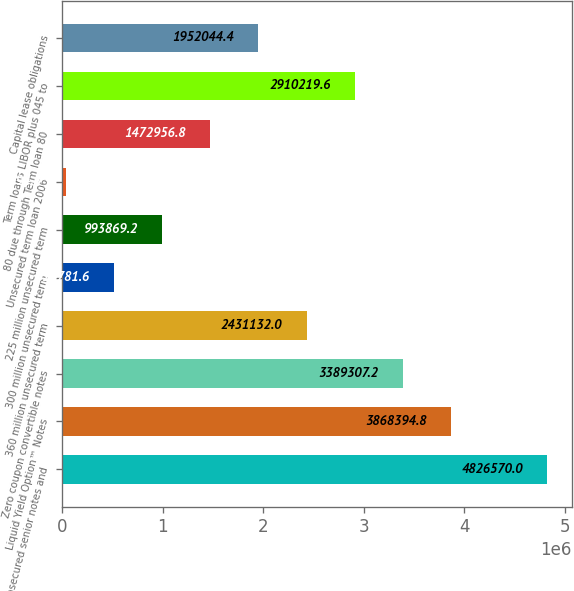Convert chart to OTSL. <chart><loc_0><loc_0><loc_500><loc_500><bar_chart><fcel>Unsecured senior notes and<fcel>Liquid Yield Option™ Notes<fcel>Zero coupon convertible notes<fcel>360 million unsecured term<fcel>300 million unsecured term<fcel>225 million unsecured term<fcel>Unsecured term loan 2006<fcel>80 due through Term loan 80<fcel>Term loans LIBOR plus 045 to<fcel>Capital lease obligations<nl><fcel>4.82657e+06<fcel>3.86839e+06<fcel>3.38931e+06<fcel>2.43113e+06<fcel>514782<fcel>993869<fcel>35694<fcel>1.47296e+06<fcel>2.91022e+06<fcel>1.95204e+06<nl></chart> 